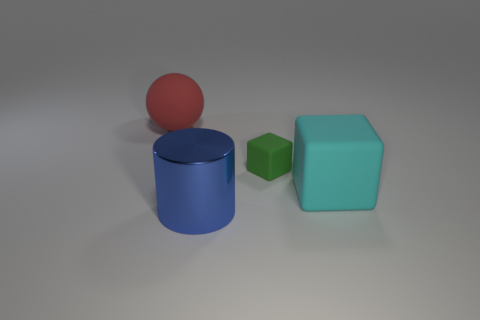Subtract all cyan cubes. How many cubes are left? 1 Subtract 1 spheres. How many spheres are left? 0 Add 2 metal cylinders. How many objects exist? 6 Add 1 small green cubes. How many small green cubes are left? 2 Add 2 small purple spheres. How many small purple spheres exist? 2 Subtract 0 yellow cubes. How many objects are left? 4 Subtract all cylinders. How many objects are left? 3 Subtract all brown cubes. Subtract all yellow spheres. How many cubes are left? 2 Subtract all blue cylinders. How many blue spheres are left? 0 Subtract all metallic objects. Subtract all balls. How many objects are left? 2 